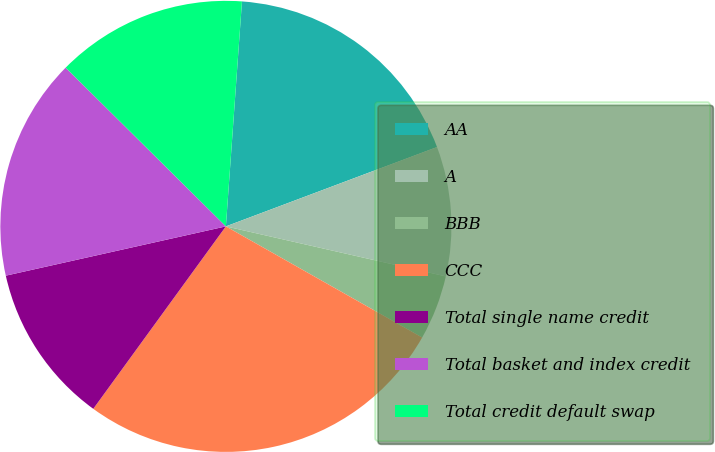Convert chart. <chart><loc_0><loc_0><loc_500><loc_500><pie_chart><fcel>AA<fcel>A<fcel>BBB<fcel>CCC<fcel>Total single name credit<fcel>Total basket and index credit<fcel>Total credit default swap<nl><fcel>18.14%<fcel>9.28%<fcel>4.64%<fcel>26.8%<fcel>11.49%<fcel>15.93%<fcel>13.71%<nl></chart> 